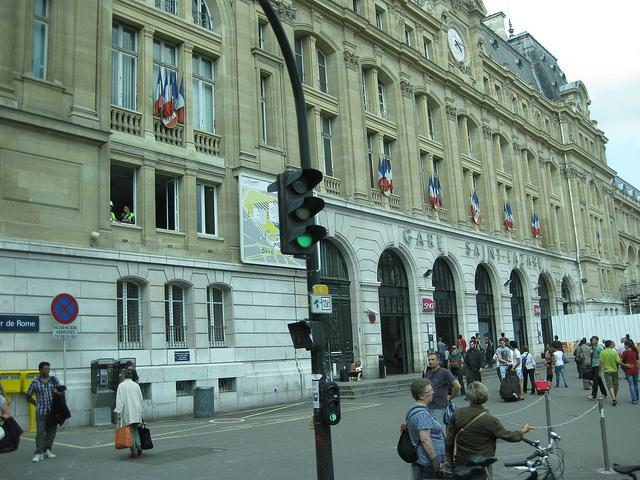What country's flag is being flown? france 